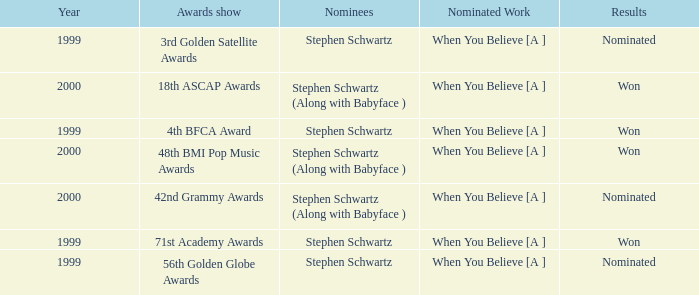Parse the table in full. {'header': ['Year', 'Awards show', 'Nominees', 'Nominated Work', 'Results'], 'rows': [['1999', '3rd Golden Satellite Awards', 'Stephen Schwartz', 'When You Believe [A ]', 'Nominated'], ['2000', '18th ASCAP Awards', 'Stephen Schwartz (Along with Babyface )', 'When You Believe [A ]', 'Won'], ['1999', '4th BFCA Award', 'Stephen Schwartz', 'When You Believe [A ]', 'Won'], ['2000', '48th BMI Pop Music Awards', 'Stephen Schwartz (Along with Babyface )', 'When You Believe [A ]', 'Won'], ['2000', '42nd Grammy Awards', 'Stephen Schwartz (Along with Babyface )', 'When You Believe [A ]', 'Nominated'], ['1999', '71st Academy Awards', 'Stephen Schwartz', 'When You Believe [A ]', 'Won'], ['1999', '56th Golden Globe Awards', 'Stephen Schwartz', 'When You Believe [A ]', 'Nominated']]} Which Nominated Work won in 2000? When You Believe [A ], When You Believe [A ]. 